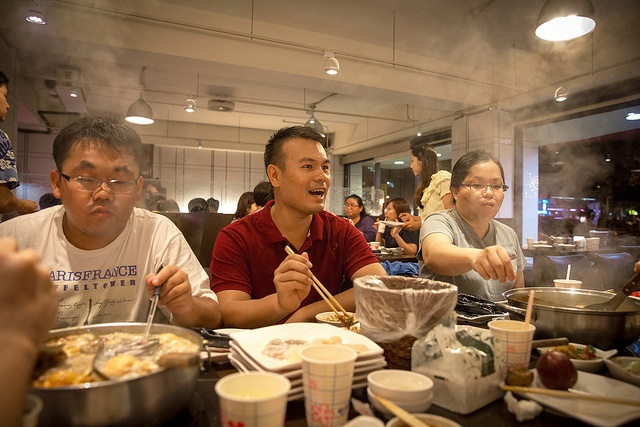Describe the objects in this image and their specific colors. I can see people in black, brown, tan, gray, and maroon tones, people in black, maroon, brown, and tan tones, people in black, gray, tan, and brown tones, people in black, maroon, brown, and tan tones, and bowl in black, gray, brown, and tan tones in this image. 